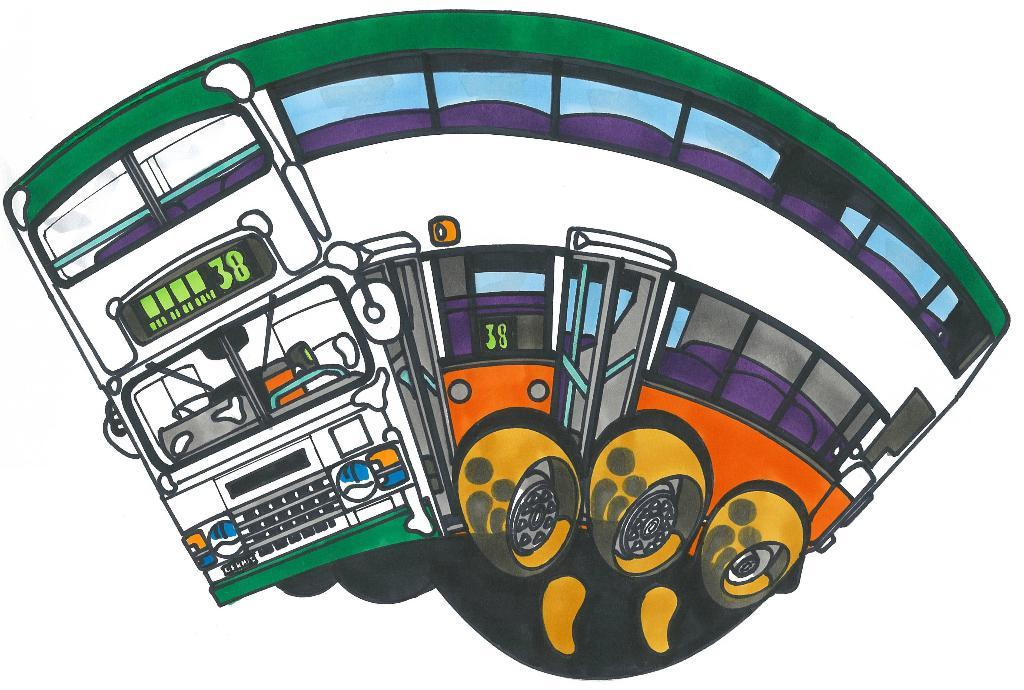What type of image is being depicted? The image is an animated image. What can be seen in the middle of the animated image? There is a bus in the middle of the image. What type of sound can be heard coming from the bus in the image? There is no sound present in the image, as it is a still image and not a video. What type of lizards can be seen on the bus in the image? There are no lizards present in the image; it features a bus in the middle. What is the color of the tongue of the lizard on the bus in the image? There are no lizards present in the image, so it is not possible to determine the color of any lizard's tongue. 